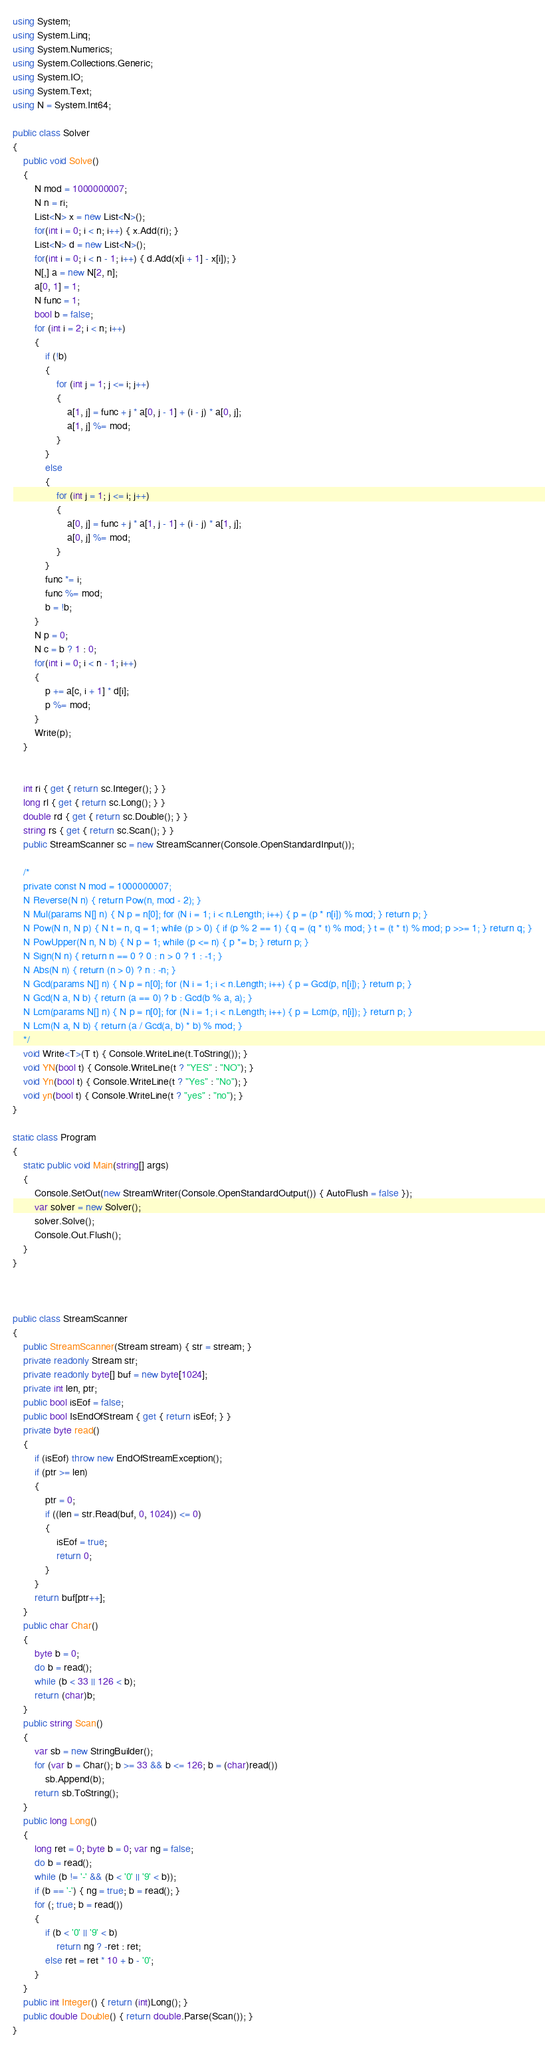<code> <loc_0><loc_0><loc_500><loc_500><_C#_>using System;
using System.Linq;
using System.Numerics;
using System.Collections.Generic;
using System.IO;
using System.Text;
using N = System.Int64;

public class Solver
{
    public void Solve()
    {
        N mod = 1000000007;
        N n = ri;
        List<N> x = new List<N>();
        for(int i = 0; i < n; i++) { x.Add(ri); }
        List<N> d = new List<N>();
        for(int i = 0; i < n - 1; i++) { d.Add(x[i + 1] - x[i]); }
        N[,] a = new N[2, n];
        a[0, 1] = 1;
        N func = 1;
        bool b = false;
        for (int i = 2; i < n; i++)
        {
            if (!b)
            {
                for (int j = 1; j <= i; j++)
                {
                    a[1, j] = func + j * a[0, j - 1] + (i - j) * a[0, j];
                    a[1, j] %= mod;
                }
            }
            else
            {
                for (int j = 1; j <= i; j++)
                {
                    a[0, j] = func + j * a[1, j - 1] + (i - j) * a[1, j];
                    a[0, j] %= mod;
                }
            }
            func *= i;
            func %= mod;
            b = !b;
        }
        N p = 0;
        N c = b ? 1 : 0;
        for(int i = 0; i < n - 1; i++)
        {
            p += a[c, i + 1] * d[i];
            p %= mod;
        }
        Write(p);
    }


    int ri { get { return sc.Integer(); } }
    long rl { get { return sc.Long(); } }
    double rd { get { return sc.Double(); } }
    string rs { get { return sc.Scan(); } }
    public StreamScanner sc = new StreamScanner(Console.OpenStandardInput());

    /*
    private const N mod = 1000000007;
    N Reverse(N n) { return Pow(n, mod - 2); }
    N Mul(params N[] n) { N p = n[0]; for (N i = 1; i < n.Length; i++) { p = (p * n[i]) % mod; } return p; }
    N Pow(N n, N p) { N t = n, q = 1; while (p > 0) { if (p % 2 == 1) { q = (q * t) % mod; } t = (t * t) % mod; p >>= 1; } return q; }
    N PowUpper(N n, N b) { N p = 1; while (p <= n) { p *= b; } return p; }
    N Sign(N n) { return n == 0 ? 0 : n > 0 ? 1 : -1; }
    N Abs(N n) { return (n > 0) ? n : -n; }
    N Gcd(params N[] n) { N p = n[0]; for (N i = 1; i < n.Length; i++) { p = Gcd(p, n[i]); } return p; }
    N Gcd(N a, N b) { return (a == 0) ? b : Gcd(b % a, a); }
    N Lcm(params N[] n) { N p = n[0]; for (N i = 1; i < n.Length; i++) { p = Lcm(p, n[i]); } return p; }
    N Lcm(N a, N b) { return (a / Gcd(a, b) * b) % mod; }
    */
    void Write<T>(T t) { Console.WriteLine(t.ToString()); }
    void YN(bool t) { Console.WriteLine(t ? "YES" : "NO"); }
    void Yn(bool t) { Console.WriteLine(t ? "Yes" : "No"); }
    void yn(bool t) { Console.WriteLine(t ? "yes" : "no"); }
}

static class Program
{
    static public void Main(string[] args)
    {
        Console.SetOut(new StreamWriter(Console.OpenStandardOutput()) { AutoFlush = false });
        var solver = new Solver();
        solver.Solve();
        Console.Out.Flush();
    }
}



public class StreamScanner
{
    public StreamScanner(Stream stream) { str = stream; }
    private readonly Stream str;
    private readonly byte[] buf = new byte[1024];
    private int len, ptr;
    public bool isEof = false;
    public bool IsEndOfStream { get { return isEof; } }
    private byte read()
    {
        if (isEof) throw new EndOfStreamException();
        if (ptr >= len)
        {
            ptr = 0;
            if ((len = str.Read(buf, 0, 1024)) <= 0)
            {
                isEof = true;
                return 0;
            }
        }
        return buf[ptr++];
    }
    public char Char()
    {
        byte b = 0;
        do b = read();
        while (b < 33 || 126 < b);
        return (char)b;
    }
    public string Scan()
    {
        var sb = new StringBuilder();
        for (var b = Char(); b >= 33 && b <= 126; b = (char)read())
            sb.Append(b);
        return sb.ToString();
    }
    public long Long()
    {
        long ret = 0; byte b = 0; var ng = false;
        do b = read();
        while (b != '-' && (b < '0' || '9' < b));
        if (b == '-') { ng = true; b = read(); }
        for (; true; b = read())
        {
            if (b < '0' || '9' < b)
                return ng ? -ret : ret;
            else ret = ret * 10 + b - '0';
        }
    }
    public int Integer() { return (int)Long(); }
    public double Double() { return double.Parse(Scan()); }
}
</code> 